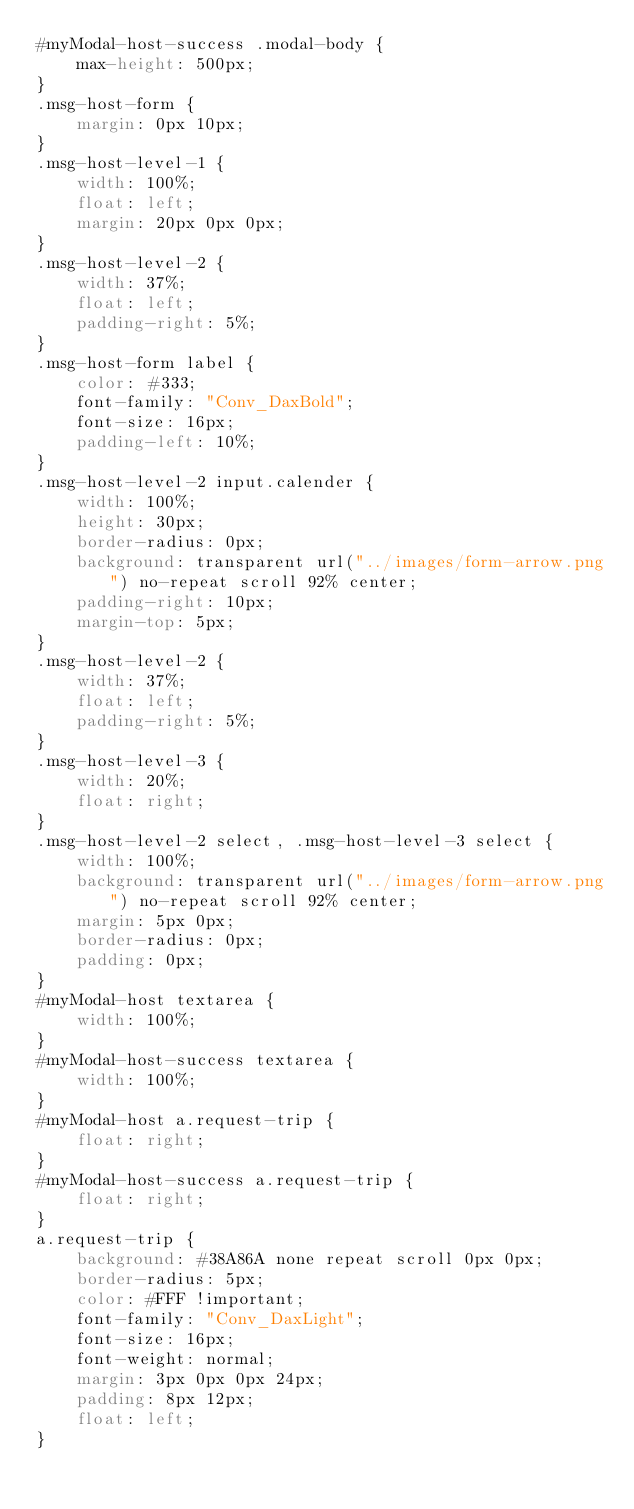Convert code to text. <code><loc_0><loc_0><loc_500><loc_500><_CSS_>#myModal-host-success .modal-body {
    max-height: 500px;
}
.msg-host-form {
    margin: 0px 10px;
}
.msg-host-level-1 {
    width: 100%;
    float: left;
    margin: 20px 0px 0px;
}
.msg-host-level-2 {
    width: 37%;
    float: left;
    padding-right: 5%;
}
.msg-host-form label {
    color: #333;
    font-family: "Conv_DaxBold";
    font-size: 16px;
    padding-left: 10%;
}
.msg-host-level-2 input.calender {
    width: 100%;
    height: 30px;
    border-radius: 0px;
    background: transparent url("../images/form-arrow.png") no-repeat scroll 92% center;
    padding-right: 10px;
    margin-top: 5px;
}
.msg-host-level-2 {
    width: 37%;
    float: left;
    padding-right: 5%;
}
.msg-host-level-3 {
    width: 20%;
    float: right;
}
.msg-host-level-2 select, .msg-host-level-3 select {
    width: 100%;
    background: transparent url("../images/form-arrow.png") no-repeat scroll 92% center;
    margin: 5px 0px;
    border-radius: 0px;
    padding: 0px;
}
#myModal-host textarea {
    width: 100%;
}
#myModal-host-success textarea {
    width: 100%;
}
#myModal-host a.request-trip {
    float: right;
}
#myModal-host-success a.request-trip {
    float: right;
}
a.request-trip {
    background: #38A86A none repeat scroll 0px 0px;
    border-radius: 5px;
    color: #FFF !important;
    font-family: "Conv_DaxLight";
    font-size: 16px;
    font-weight: normal;
    margin: 3px 0px 0px 24px;
    padding: 8px 12px;
    float: left;
}
</code> 